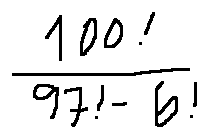Convert formula to latex. <formula><loc_0><loc_0><loc_500><loc_500>\frac { 1 0 0 ! } { 9 7 ! - 6 ! }</formula> 